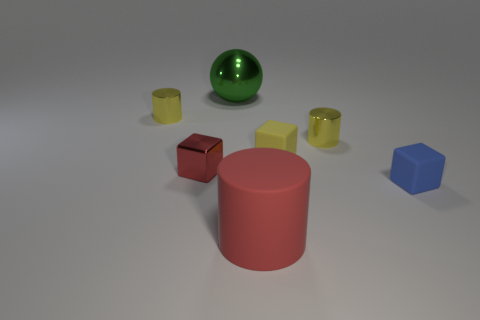Subtract all tiny rubber cubes. How many cubes are left? 1 Add 3 tiny rubber things. How many objects exist? 10 Subtract 1 cubes. How many cubes are left? 2 Subtract all balls. How many objects are left? 6 Subtract all gray spheres. How many red cylinders are left? 1 Subtract all tiny cylinders. Subtract all red blocks. How many objects are left? 4 Add 4 rubber cubes. How many rubber cubes are left? 6 Add 4 big brown metallic balls. How many big brown metallic balls exist? 4 Subtract all red cubes. How many cubes are left? 2 Subtract 0 cyan cylinders. How many objects are left? 7 